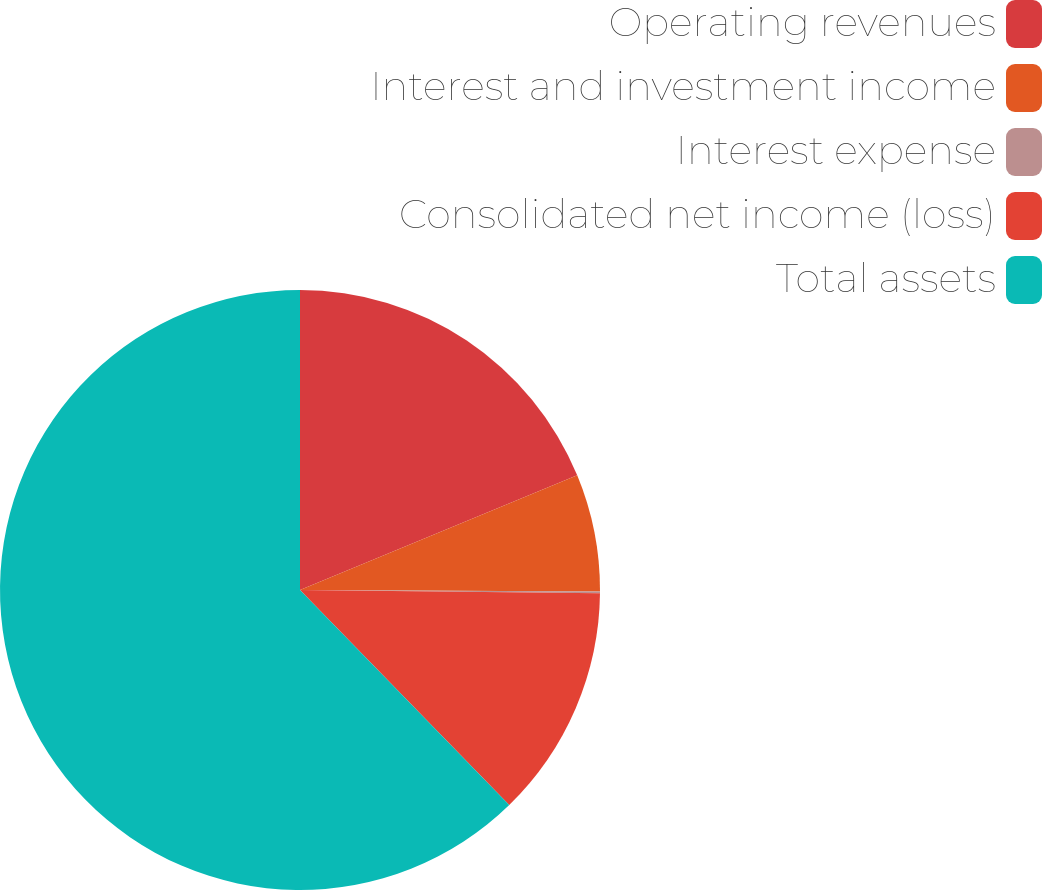Convert chart. <chart><loc_0><loc_0><loc_500><loc_500><pie_chart><fcel>Operating revenues<fcel>Interest and investment income<fcel>Interest expense<fcel>Consolidated net income (loss)<fcel>Total assets<nl><fcel>18.76%<fcel>6.32%<fcel>0.1%<fcel>12.54%<fcel>62.29%<nl></chart> 